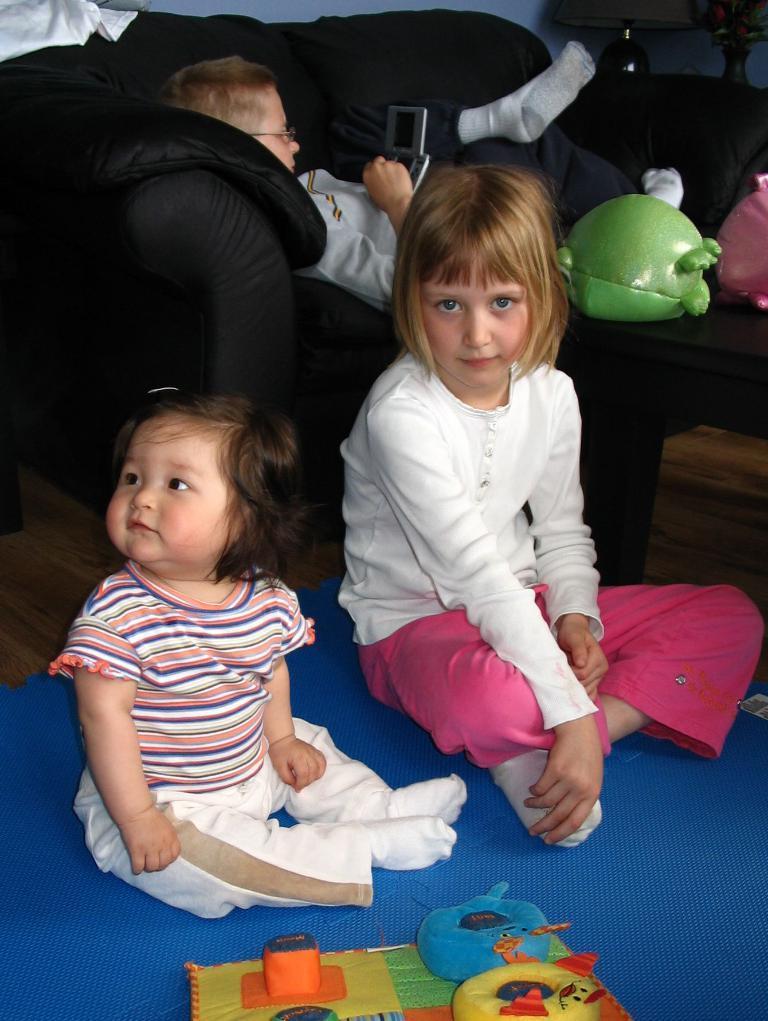How would you summarize this image in a sentence or two? In this image in the center there are two girls who are sitting, in front of them there are some toys. And in the background there is a couch, on the couch there is one boy who is lying and he is holding a phone. On the right side there is a table, on the table there are some toys and on the top of the right corner there is a lamp and a table. 